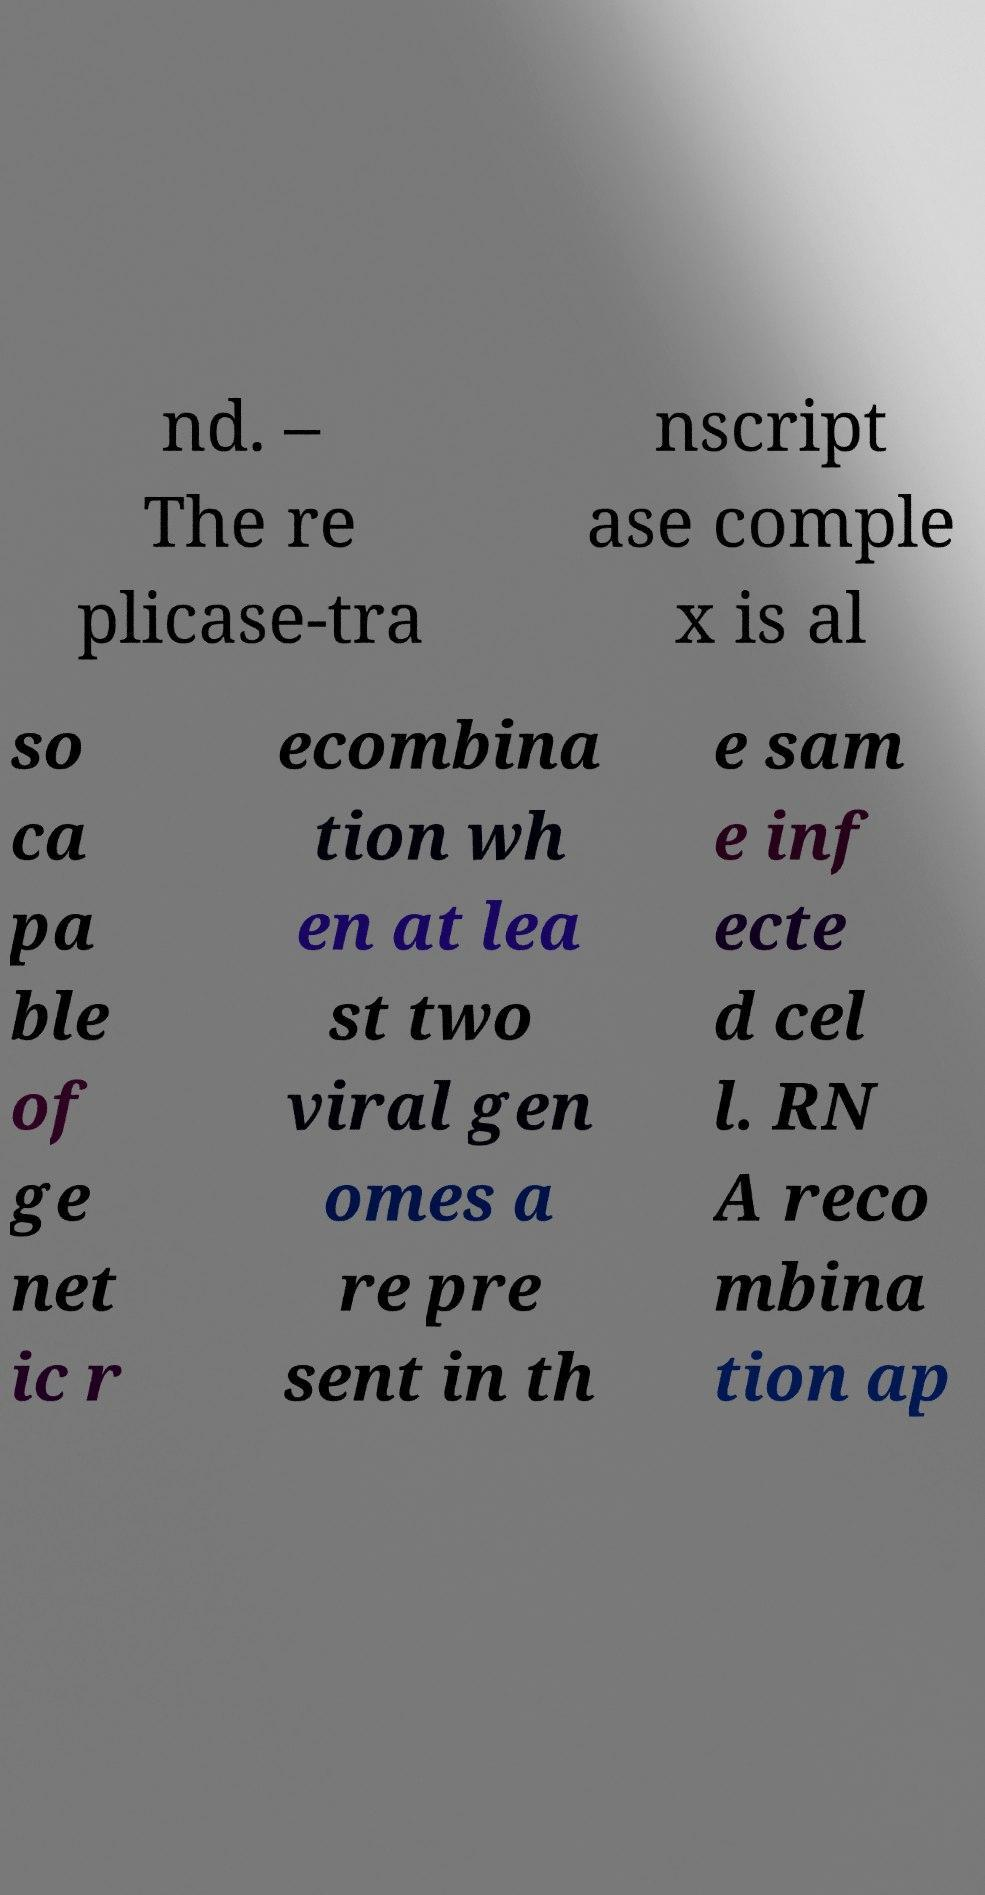What messages or text are displayed in this image? I need them in a readable, typed format. nd. – The re plicase-tra nscript ase comple x is al so ca pa ble of ge net ic r ecombina tion wh en at lea st two viral gen omes a re pre sent in th e sam e inf ecte d cel l. RN A reco mbina tion ap 